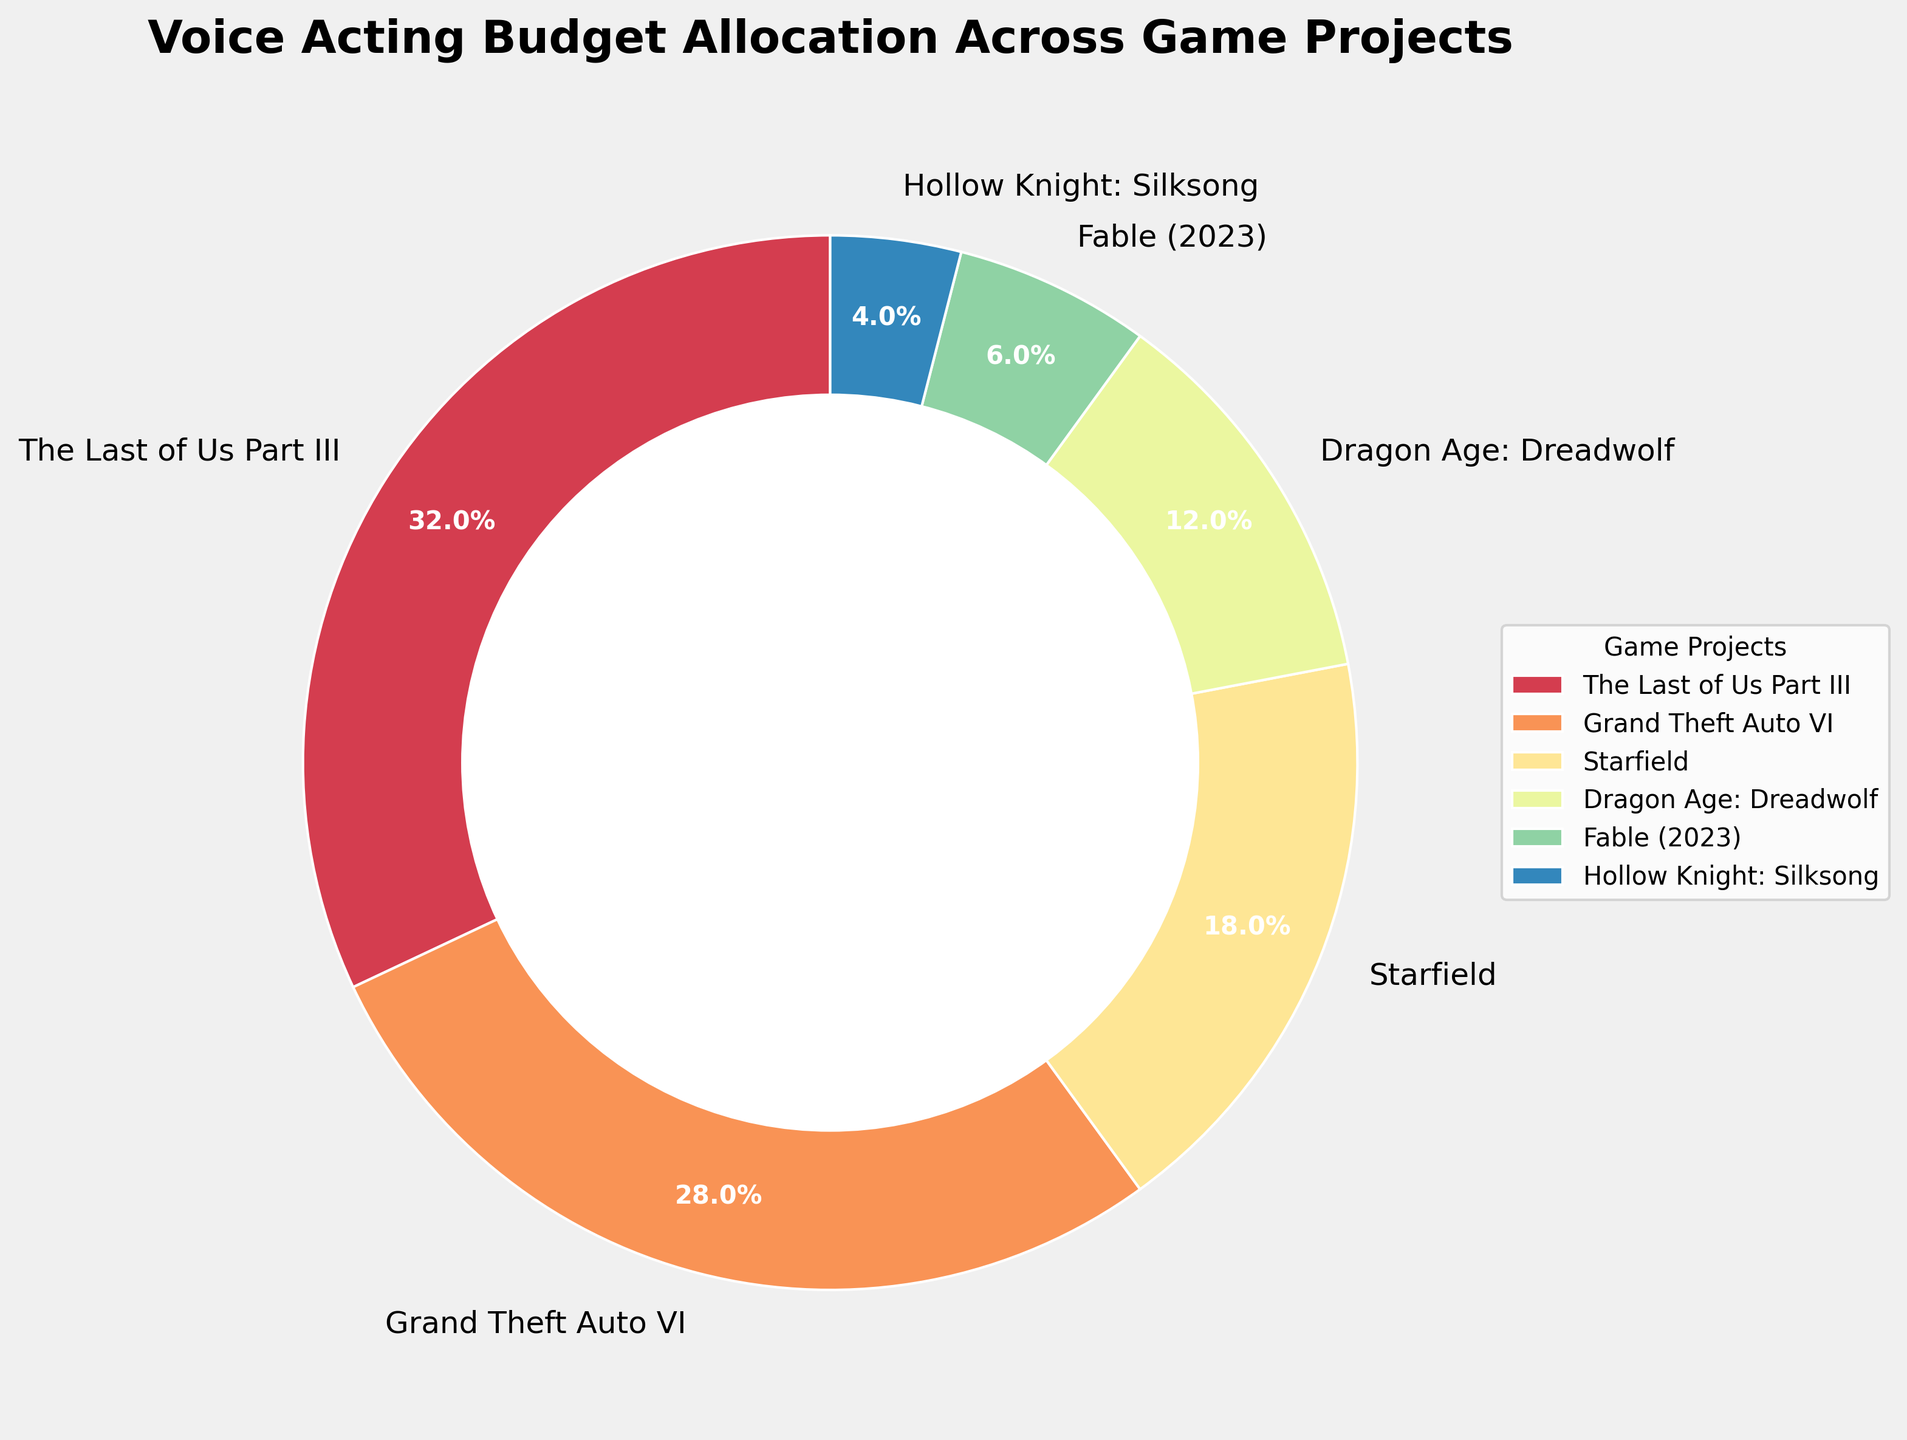Which project has the highest budget allocation? The sector with the largest size represents the project with the highest budget allocation. From the figure, this would be the project labeled "The Last of Us Part III"
Answer: The Last of Us Part III How much more budget allocation does "The Last of Us Part III" have compared to "Starfield"? To answer this, calculate the difference between the budget allocations of "The Last of Us Part III" and "Starfield". From the figure, "The Last of Us Part III" has 32% and "Starfield" has 18%. So, 32% - 18% = 14%
Answer: 14% Which projects together make up more than 50% of the total budget? Identify and sum the budget allocations of the largest sectors until the sum exceeds 50%. Here, "The Last of Us Part III" (32%) and "Grand Theft Auto VI" (28%) together sum to 60%.
Answer: The Last of Us Part III and Grand Theft Auto VI What is the approximate combined budget allocation of "Dragon Age: Dreadwolf" and "Fable (2023)"? Add the budget allocations of "Dragon Age: Dreadwolf" and "Fable (2023)". From the figure, it's 12% + 6% = 18%
Answer: 18% Is the budget allocation for "Hollow Knight: Silksong" greater than any other project? Compare the allocation of "Hollow Knight: Silksong" with other projects. It has a 4% allocation, which is less than all other projects (32%, 28%, 18%, 12%, and 6%).
Answer: No Which project(s) have a budget allocation greater than 20%? Identify the sectors with more than 20%. "The Last of Us Part III" has 32% and "Grand Theft Auto VI" has 28%.
Answer: The Last of Us Part III and Grand Theft Auto VI What is the difference in budget allocation between "Grand Theft Auto VI" and "Dragon Age: Dreadwolf"? Calculate the difference: 28% (Grand Theft Auto VI) - 12% (Dragon Age: Dreadwolf) = 16%
Answer: 16% Which color represents the project with the third highest budget allocation? Determine the project with the third highest budget allocation and then identify the color assigned to that sector. "Starfield" has the third highest at 18%, which is represented by the color in the corresponding sector.
Answer: Starfield's color Are there any projects with budget allocations less than or equal to 10%? Scan for sectors with allocations less than or equal to 10%. "Fable (2023)" has 6% and "Hollow Knight: Silksong" has 4%.
Answer: Fable (2023) and Hollow Knight: Silksong 